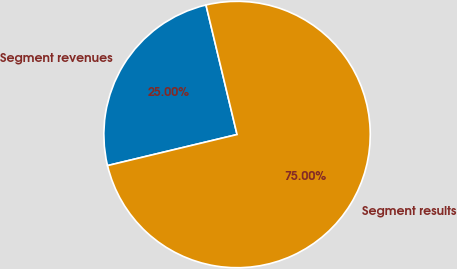Convert chart to OTSL. <chart><loc_0><loc_0><loc_500><loc_500><pie_chart><fcel>Segment revenues<fcel>Segment results<nl><fcel>25.0%<fcel>75.0%<nl></chart> 